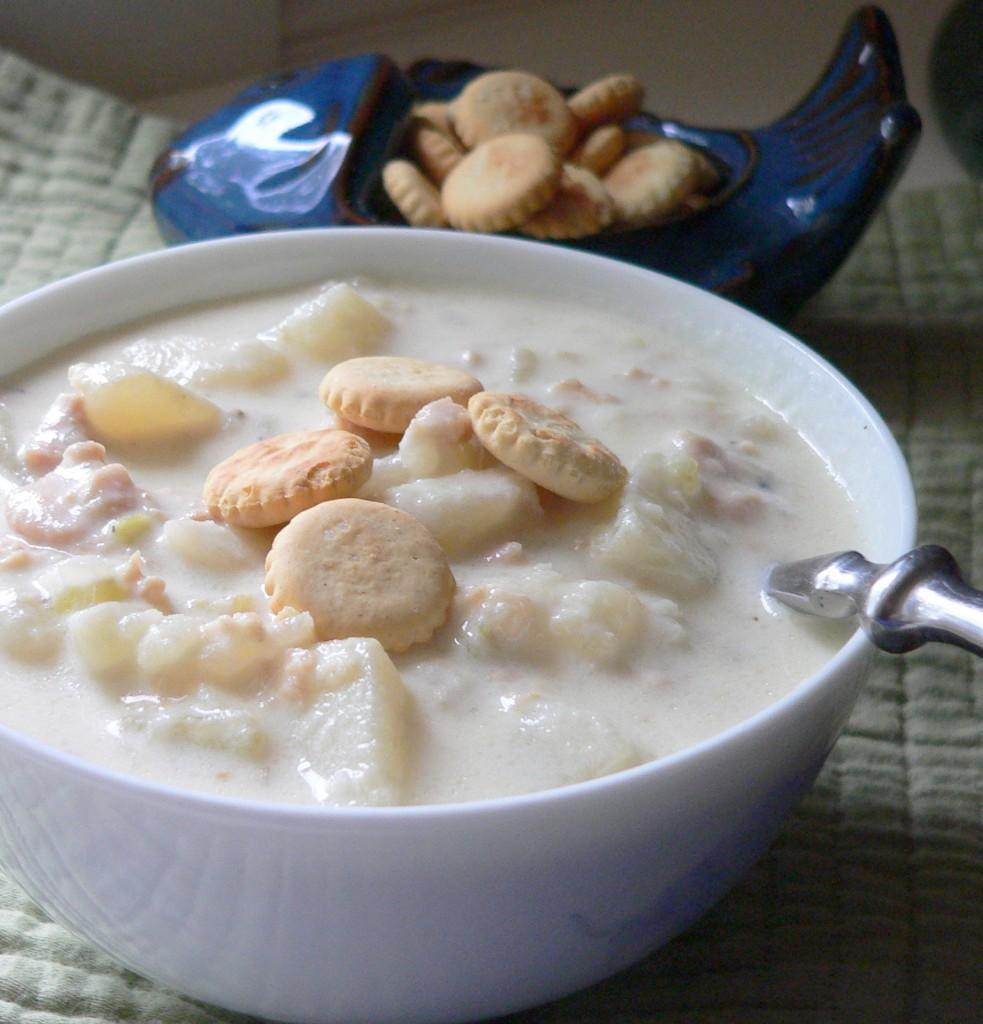How many bowls with food items are in the image? There are two bowls with food items in the image. What is the surface on which the bowls are placed? The bowls are on a cloth. Can you describe any utensils present in the image? There is an object that looks like a spoon in one of the bowls. Is there a bridge visible in the image? No, there is no bridge present in the image. What type of animal can be seen interacting with the food items in the image? There are no animals visible in the image; it only features bowls with food items and a spoon-like object. 